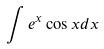<formula> <loc_0><loc_0><loc_500><loc_500>\int e ^ { x } \cos x d x</formula> 